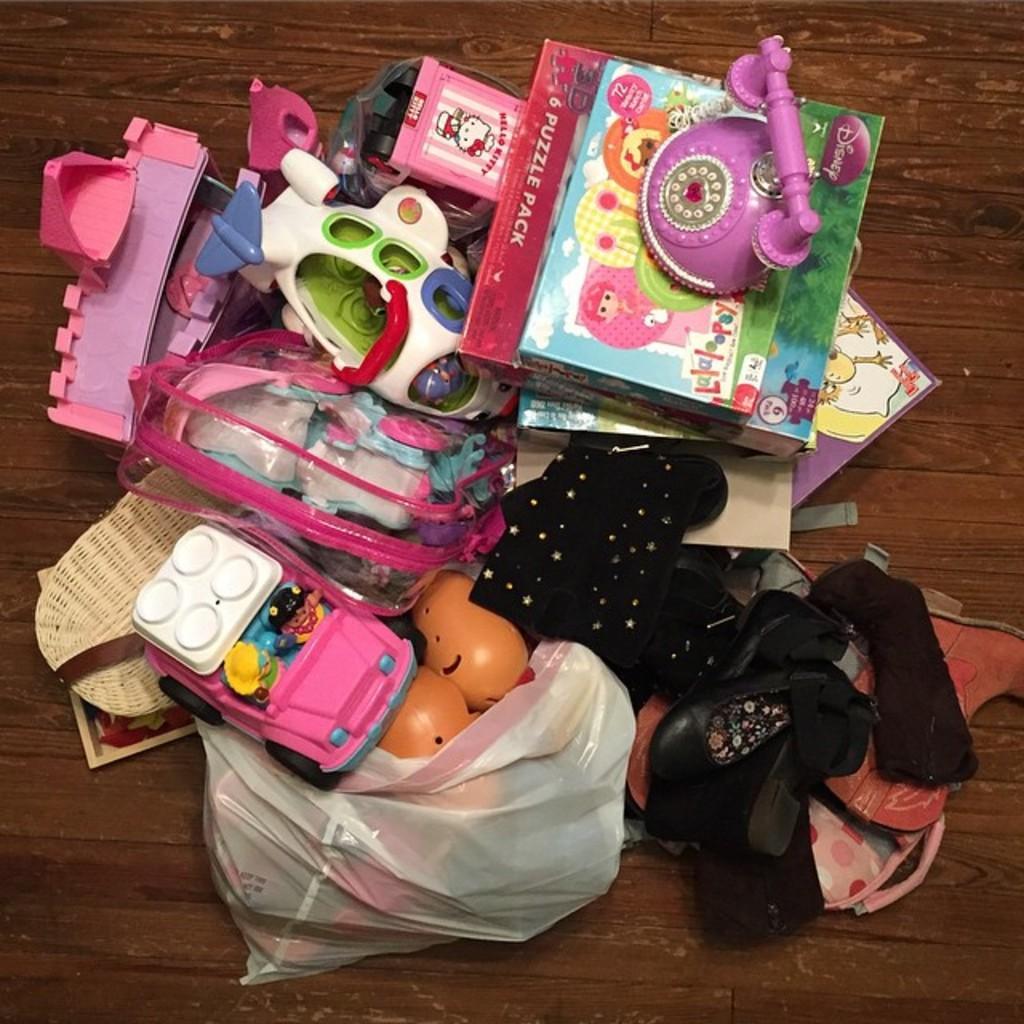How would you summarize this image in a sentence or two? In this image there are few toys, forswears and some other objects on the table. 